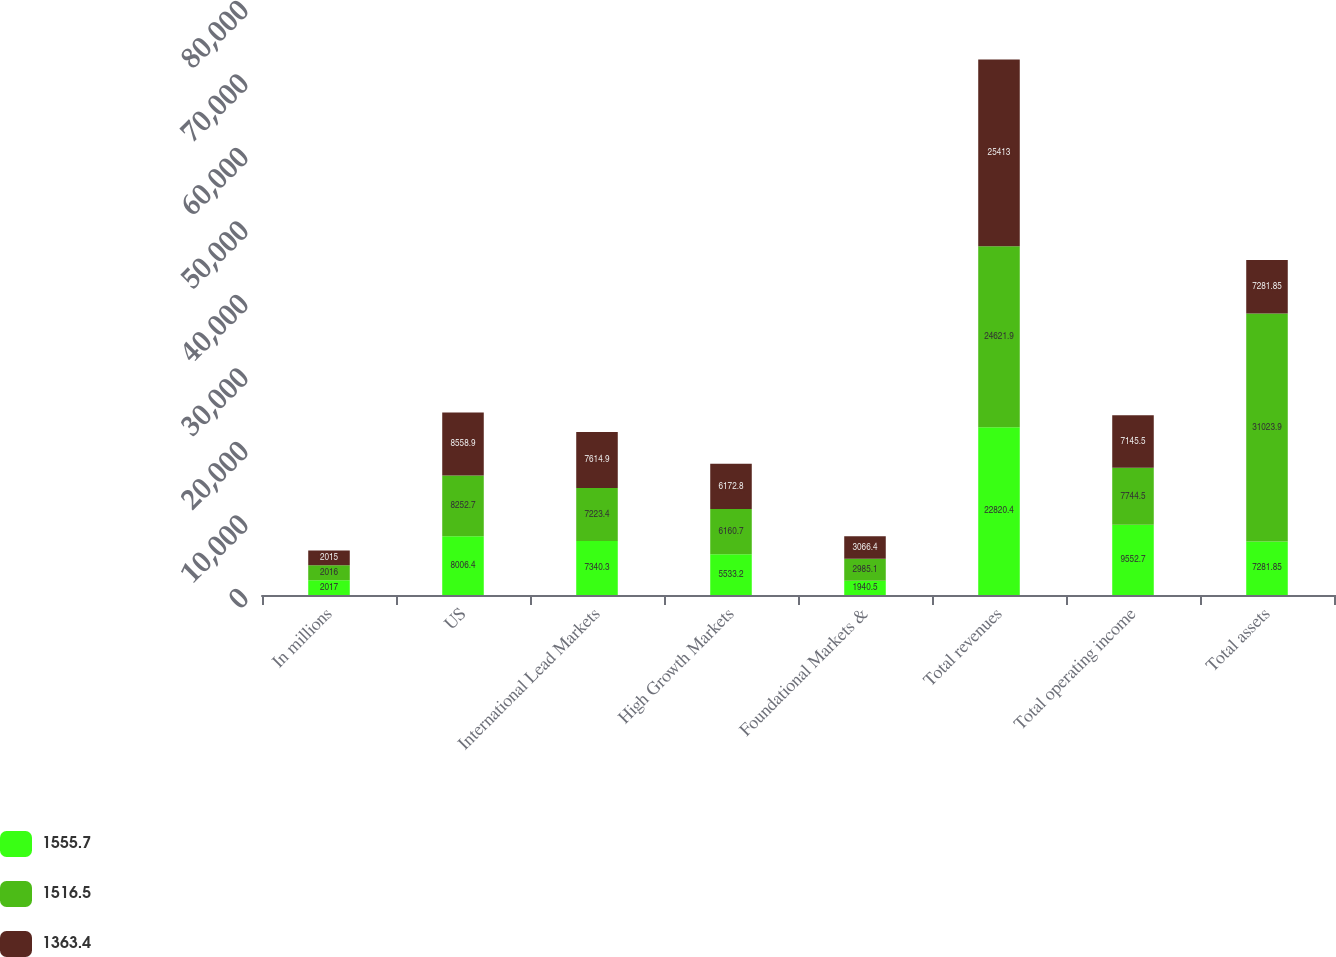Convert chart. <chart><loc_0><loc_0><loc_500><loc_500><stacked_bar_chart><ecel><fcel>In millions<fcel>US<fcel>International Lead Markets<fcel>High Growth Markets<fcel>Foundational Markets &<fcel>Total revenues<fcel>Total operating income<fcel>Total assets<nl><fcel>1555.7<fcel>2017<fcel>8006.4<fcel>7340.3<fcel>5533.2<fcel>1940.5<fcel>22820.4<fcel>9552.7<fcel>7281.85<nl><fcel>1516.5<fcel>2016<fcel>8252.7<fcel>7223.4<fcel>6160.7<fcel>2985.1<fcel>24621.9<fcel>7744.5<fcel>31023.9<nl><fcel>1363.4<fcel>2015<fcel>8558.9<fcel>7614.9<fcel>6172.8<fcel>3066.4<fcel>25413<fcel>7145.5<fcel>7281.85<nl></chart> 